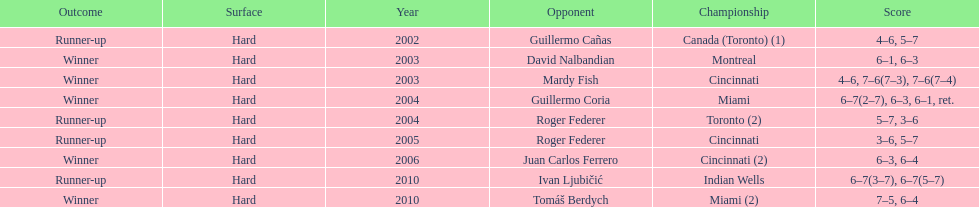What is his highest number of consecutive wins? 3. 